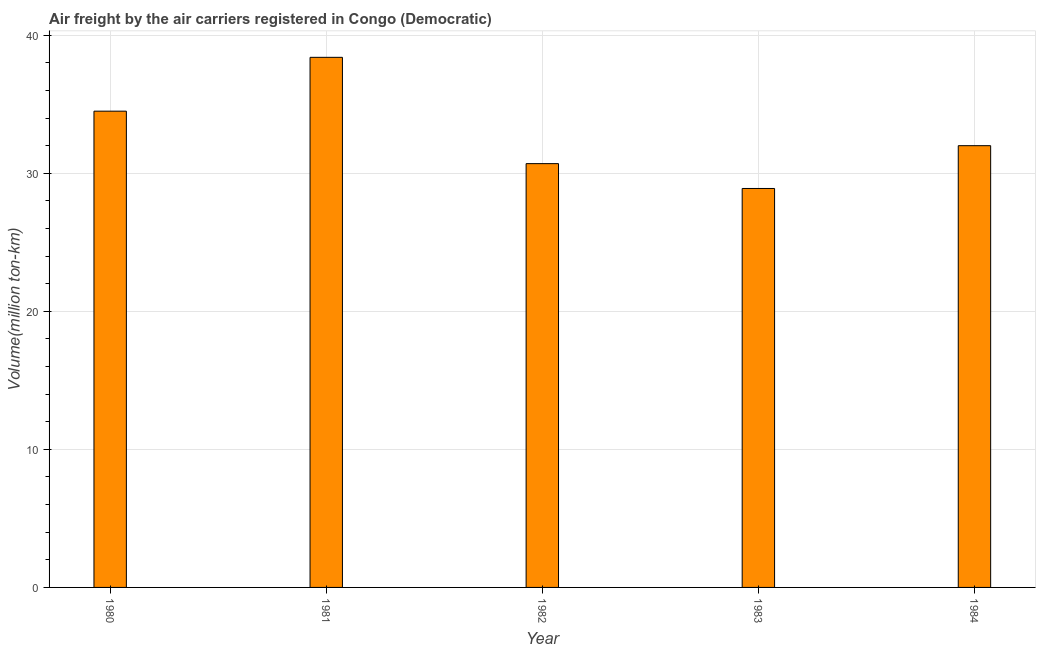Does the graph contain any zero values?
Provide a short and direct response. No. What is the title of the graph?
Your answer should be very brief. Air freight by the air carriers registered in Congo (Democratic). What is the label or title of the Y-axis?
Keep it short and to the point. Volume(million ton-km). What is the air freight in 1980?
Keep it short and to the point. 34.5. Across all years, what is the maximum air freight?
Your answer should be compact. 38.4. Across all years, what is the minimum air freight?
Provide a short and direct response. 28.9. What is the sum of the air freight?
Provide a short and direct response. 164.5. What is the average air freight per year?
Your answer should be very brief. 32.9. What is the median air freight?
Provide a short and direct response. 32. What is the ratio of the air freight in 1983 to that in 1984?
Ensure brevity in your answer.  0.9. Are all the bars in the graph horizontal?
Make the answer very short. No. What is the Volume(million ton-km) of 1980?
Your response must be concise. 34.5. What is the Volume(million ton-km) in 1981?
Make the answer very short. 38.4. What is the Volume(million ton-km) in 1982?
Keep it short and to the point. 30.7. What is the Volume(million ton-km) in 1983?
Your answer should be compact. 28.9. What is the difference between the Volume(million ton-km) in 1980 and 1981?
Ensure brevity in your answer.  -3.9. What is the difference between the Volume(million ton-km) in 1980 and 1982?
Offer a very short reply. 3.8. What is the difference between the Volume(million ton-km) in 1980 and 1983?
Your response must be concise. 5.6. What is the difference between the Volume(million ton-km) in 1980 and 1984?
Your response must be concise. 2.5. What is the difference between the Volume(million ton-km) in 1983 and 1984?
Make the answer very short. -3.1. What is the ratio of the Volume(million ton-km) in 1980 to that in 1981?
Make the answer very short. 0.9. What is the ratio of the Volume(million ton-km) in 1980 to that in 1982?
Ensure brevity in your answer.  1.12. What is the ratio of the Volume(million ton-km) in 1980 to that in 1983?
Ensure brevity in your answer.  1.19. What is the ratio of the Volume(million ton-km) in 1980 to that in 1984?
Offer a terse response. 1.08. What is the ratio of the Volume(million ton-km) in 1981 to that in 1982?
Your answer should be compact. 1.25. What is the ratio of the Volume(million ton-km) in 1981 to that in 1983?
Your answer should be compact. 1.33. What is the ratio of the Volume(million ton-km) in 1982 to that in 1983?
Offer a very short reply. 1.06. What is the ratio of the Volume(million ton-km) in 1982 to that in 1984?
Offer a very short reply. 0.96. What is the ratio of the Volume(million ton-km) in 1983 to that in 1984?
Ensure brevity in your answer.  0.9. 